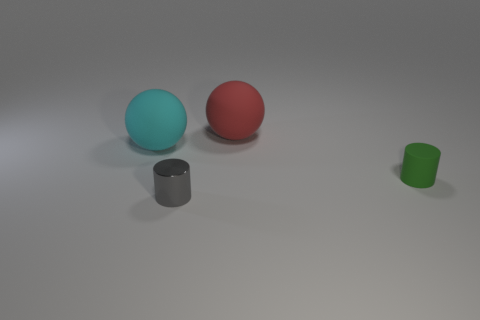Add 2 large cyan rubber cubes. How many objects exist? 6 Subtract all cyan rubber balls. Subtract all small rubber things. How many objects are left? 2 Add 1 small gray objects. How many small gray objects are left? 2 Add 2 big cyan matte balls. How many big cyan matte balls exist? 3 Subtract 0 gray spheres. How many objects are left? 4 